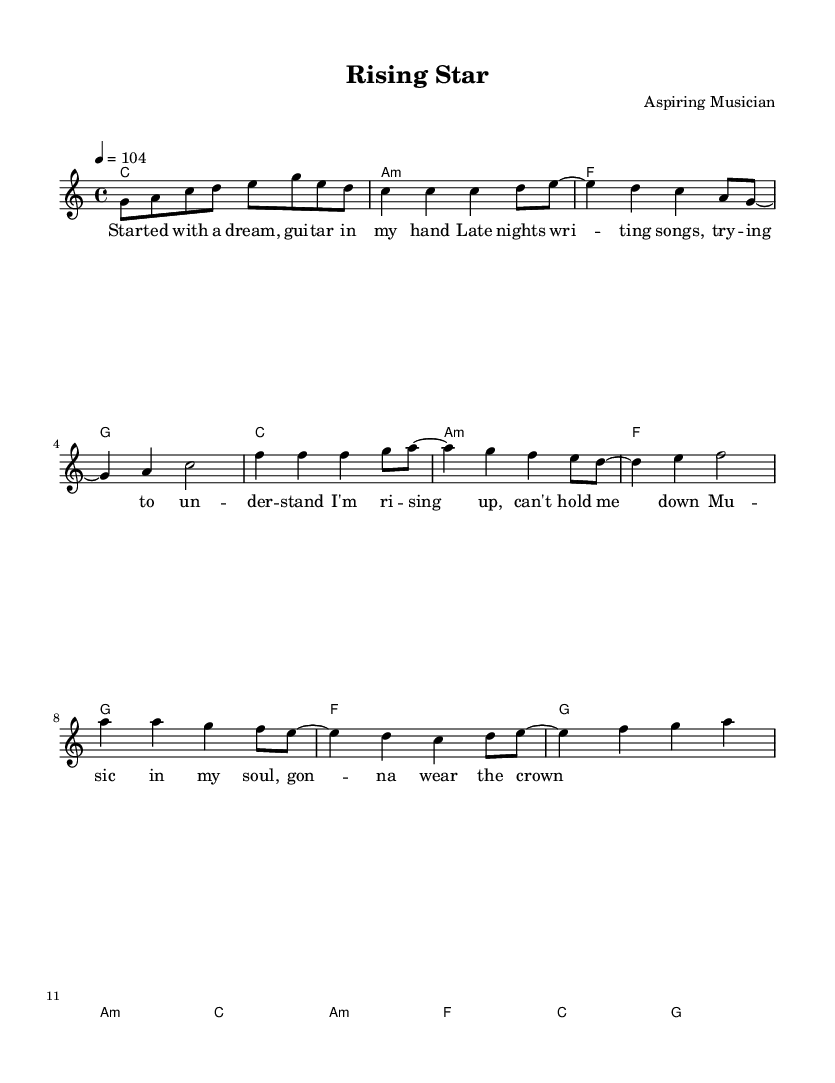What is the key signature of this music? The key signature is C major, which has no sharps or flats indicated at the beginning of the staff.
Answer: C major What is the time signature of the piece? The time signature is indicated as 4/4, meaning there are four beats in each measure and the quarter note receives one beat.
Answer: 4/4 What is the tempo marking of the song? The tempo marking shows that the piece should be played at a speed of 104 beats per minute, indicated with "4 = 104" at the beginning of the score.
Answer: 104 How many measures are in the verse section? The verse can be identified by looking at the melody and lyrics sections; there are four measures containing the verse lyrics.
Answer: 4 measures Which section follows the verse? By analyzing the structure of the song, it is clear that the chorus directly follows the verse, as indicated by the arrangement of the melody and the corresponding lyrics.
Answer: Chorus What is the mood of the lyrics in the chorus? The lyrics in the chorus express a positive and uplifting vibe, reflecting the aspirations and determination of the musician, consistent with the happy and encouraging tone typical of reggae music.
Answer: Upbeat What chords are used in the chorus? The chords in the chorus are F, G, A minor, and C, based on the chord progression provided in the harmonies section of the score for that part of the song.
Answer: F, G, A minor, C 